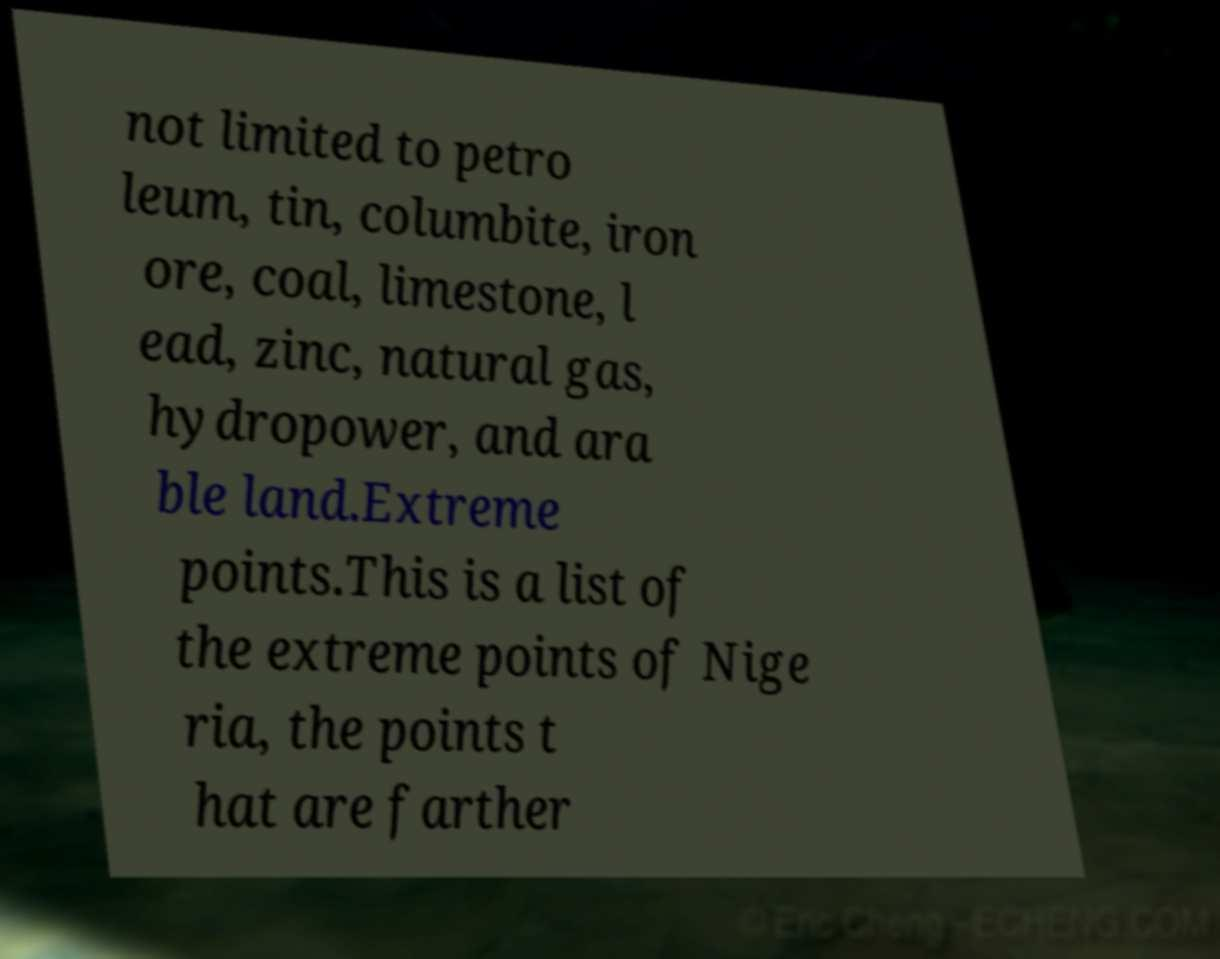Can you read and provide the text displayed in the image?This photo seems to have some interesting text. Can you extract and type it out for me? not limited to petro leum, tin, columbite, iron ore, coal, limestone, l ead, zinc, natural gas, hydropower, and ara ble land.Extreme points.This is a list of the extreme points of Nige ria, the points t hat are farther 